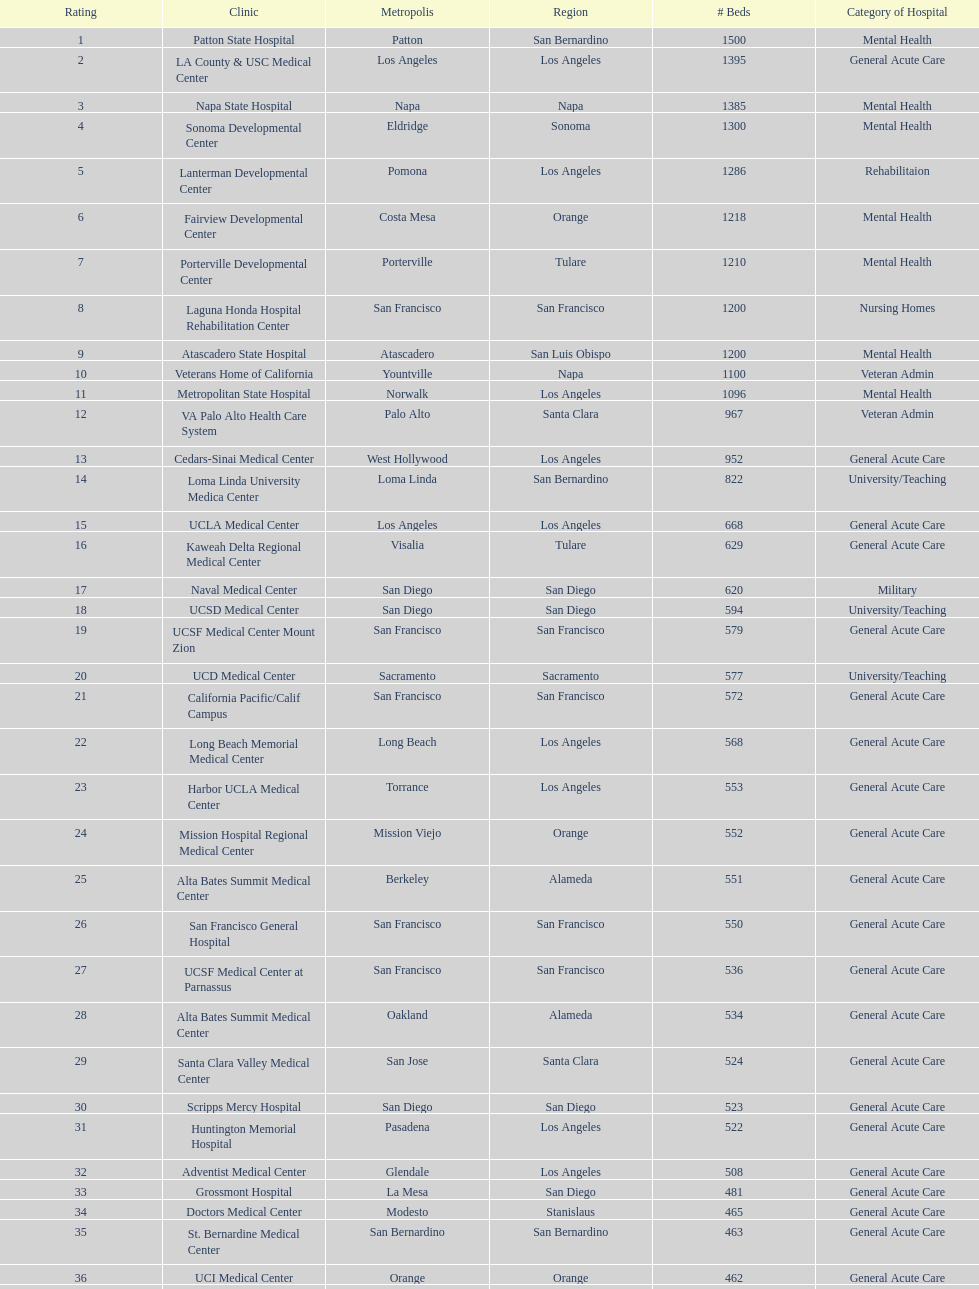Does patton state hospital in the city of patton in san bernardino county have more mental health hospital beds than atascadero state hospital in atascadero, san luis obispo county? Yes. 